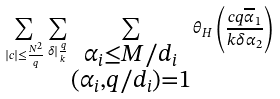Convert formula to latex. <formula><loc_0><loc_0><loc_500><loc_500>\sum _ { | c | \leq \frac { N ^ { 2 } } { q } } \sum _ { \delta | \frac { q } { k } } \sum _ { \substack { \alpha _ { i } \leq M / d _ { i } \\ ( \alpha _ { i } , q / d _ { i } ) = 1 } } \theta _ { H } \left ( \frac { c q \overline { \alpha } _ { 1 } } { k \delta \alpha _ { 2 } } \right )</formula> 